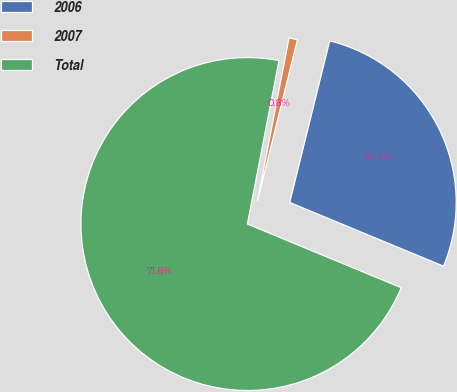Convert chart to OTSL. <chart><loc_0><loc_0><loc_500><loc_500><pie_chart><fcel>2006<fcel>2007<fcel>Total<nl><fcel>27.39%<fcel>0.82%<fcel>71.79%<nl></chart> 